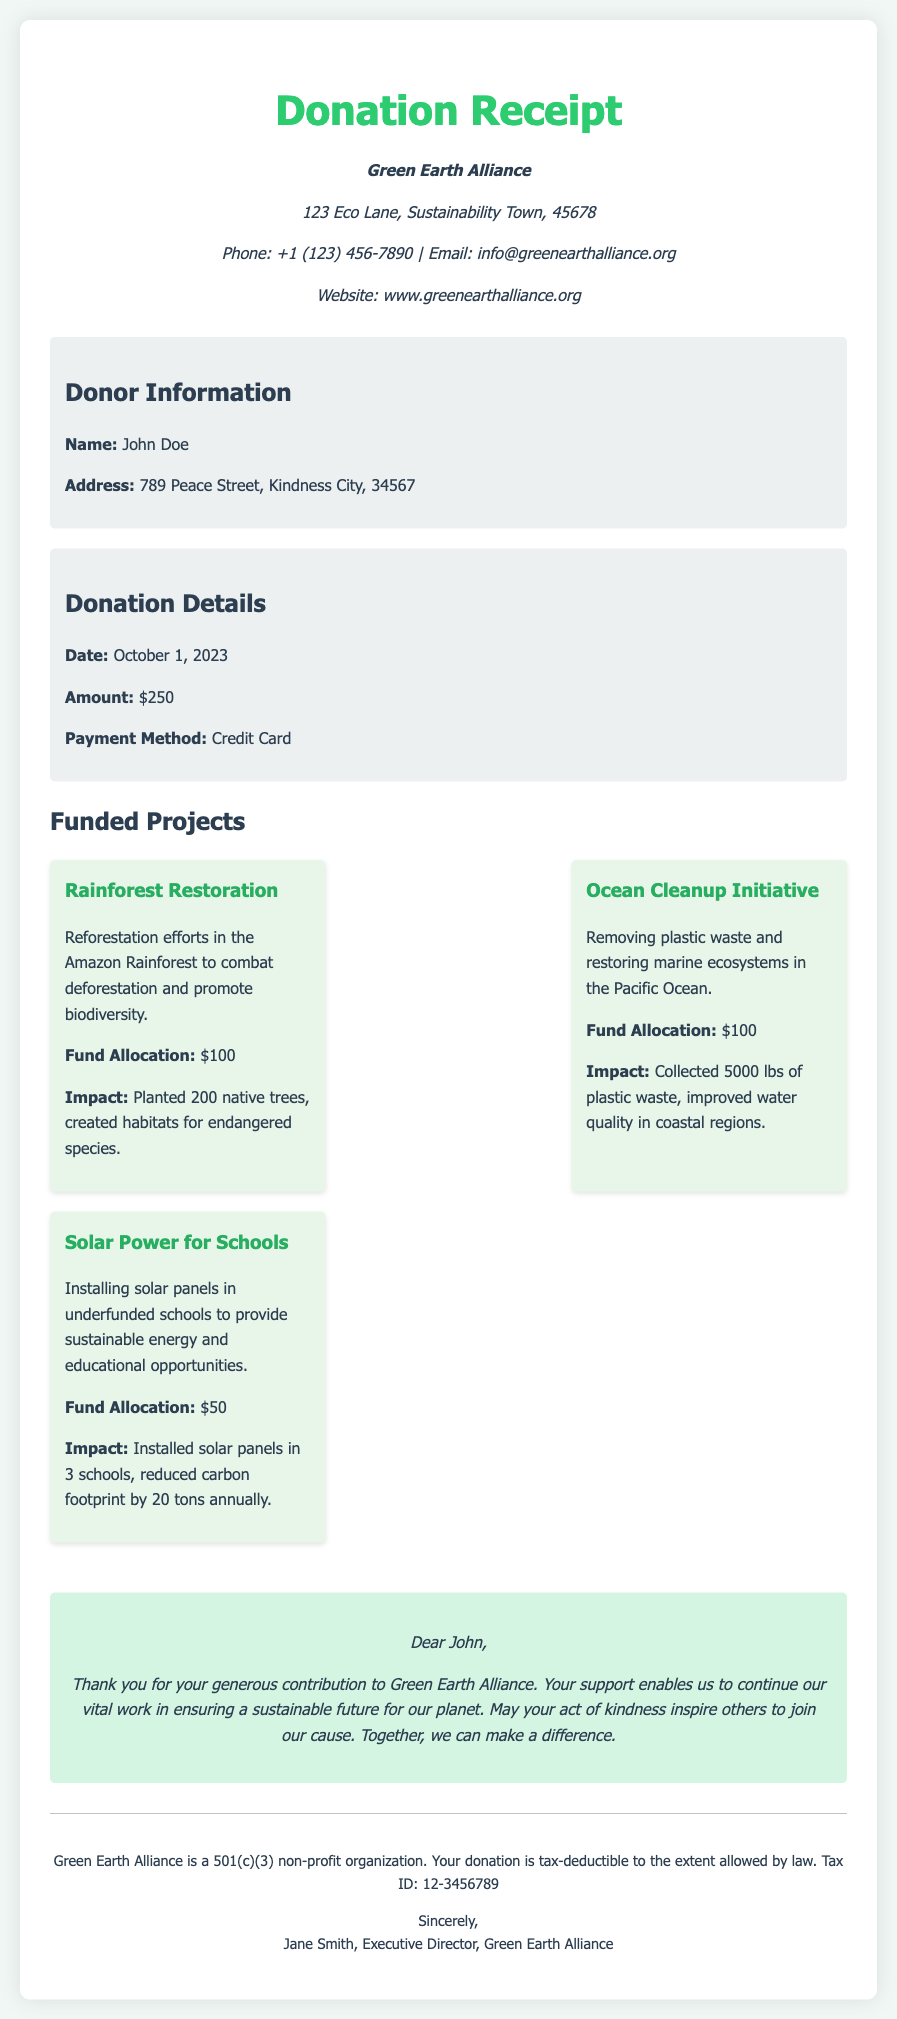What is the name of the organization? The organization associated with the donation is mentioned at the top of the receipt.
Answer: Green Earth Alliance What is the donor's name? The document lists the name of the donor in the donor information section.
Answer: John Doe What was the donation amount? The amount donated is stated clearly in the donation details section.
Answer: $250 How much funding was allocated to the Solar Power for Schools project? The allocation for each project is provided in the funded projects section.
Answer: $50 What is one impact of the Ocean Cleanup Initiative? The impact is described in the project details under the funded projects section.
Answer: Collected 5000 lbs of plastic waste What date was the donation made? The date of the donation appears in the donation details section.
Answer: October 1, 2023 How many native trees were planted in the Rainforest Restoration project? The number of trees planted is specified in the project impact details.
Answer: 200 What is the tax ID of Green Earth Alliance? The tax identification number appears at the footer of the document.
Answer: 12-3456789 What is the primary focus of the Green Earth Alliance? The organization's mission is implied through the funded projects and appreciation section.
Answer: Environmental advocacy 